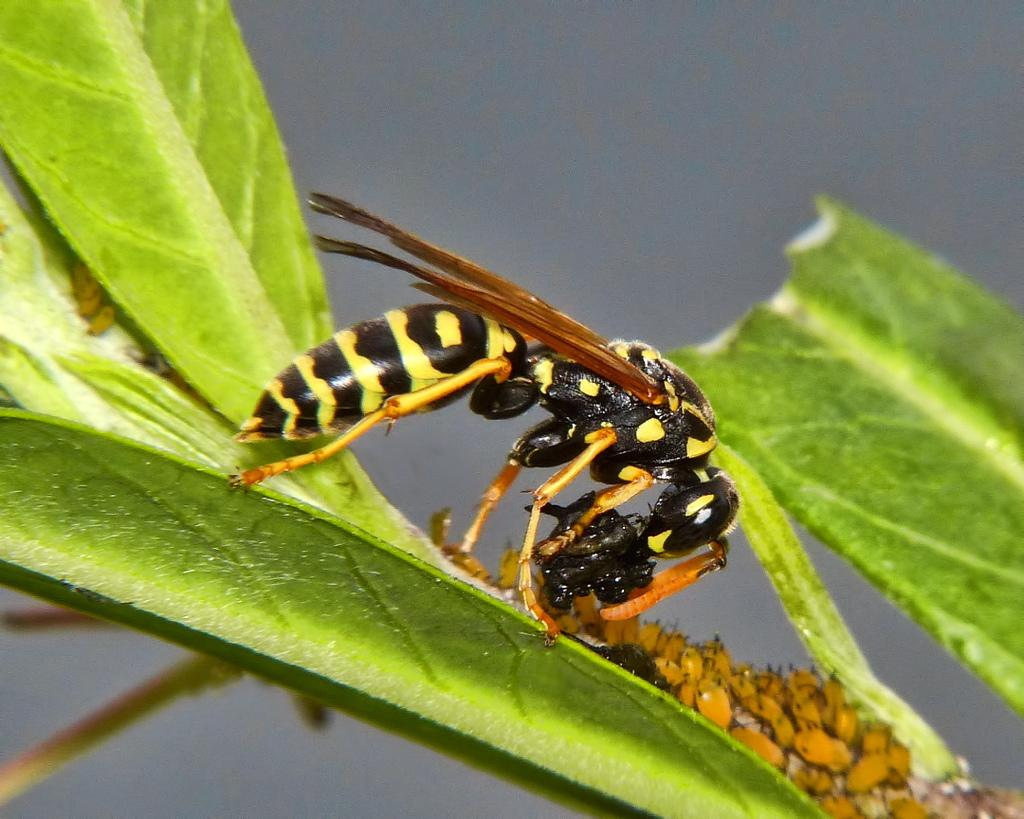Where was the image taken? The image is taken outdoors. What can be seen in the background of the image? There is the sky visible in the background. What type of vegetation is present in the image? There are a few leaves in the middle of the image. What is the structure that connects the leaves in the image? There is a stem in the image. What type of living organism can be seen on one of the leaves? There is an insect on one of the leaves. Can you see a snail on the farm in the image? There is no farm present in the image, and no snail can be seen. 